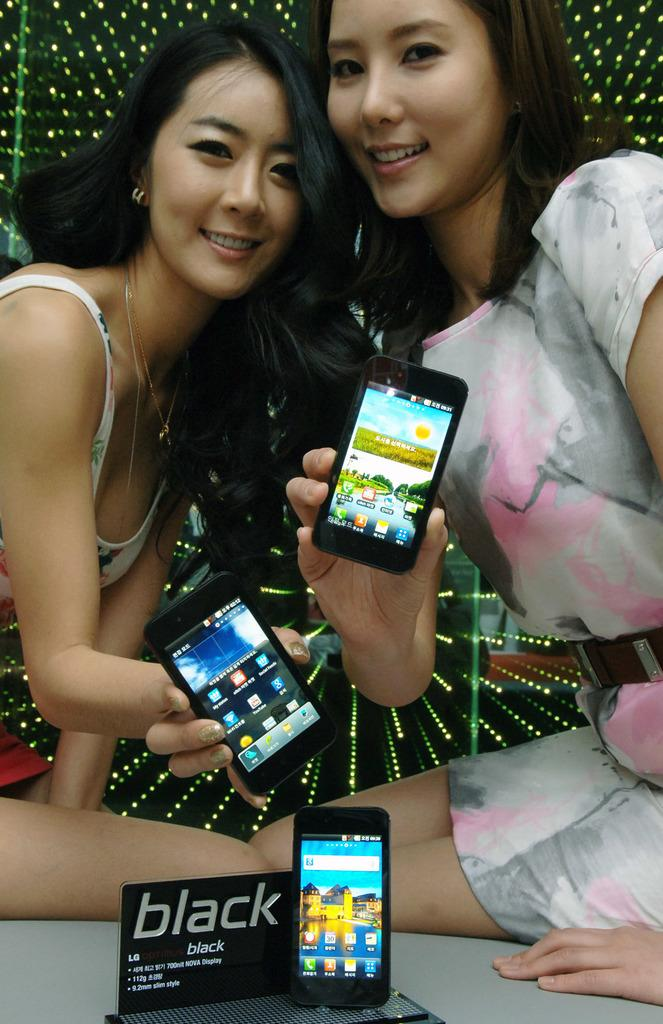<image>
Write a terse but informative summary of the picture. Two women holding phones and posing in front of a sign that says "Black". 